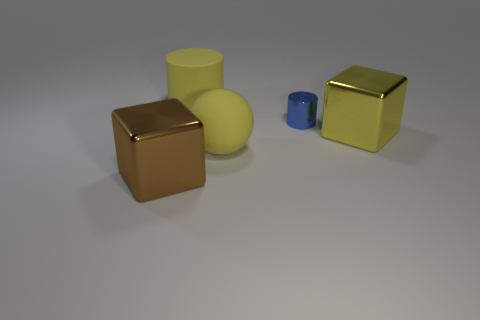Are there any other things that have the same size as the blue object?
Your answer should be very brief. No. Are there any brown cubes of the same size as the brown object?
Offer a terse response. No. Is the number of large brown metallic blocks that are behind the yellow metal cube less than the number of small brown spheres?
Offer a terse response. No. Does the yellow cylinder have the same size as the matte ball?
Give a very brief answer. Yes. What size is the thing that is made of the same material as the big ball?
Give a very brief answer. Large. How many big matte things are the same color as the large cylinder?
Make the answer very short. 1. Is the number of metal cylinders on the left side of the tiny metal cylinder less than the number of things left of the large brown metallic cube?
Your answer should be very brief. No. Is the shape of the large shiny object that is to the left of the small blue shiny object the same as  the blue metallic object?
Your response must be concise. No. Do the big cube that is behind the big brown cube and the small blue cylinder have the same material?
Keep it short and to the point. Yes. The cylinder that is behind the shiny cylinder behind the big block right of the large sphere is made of what material?
Make the answer very short. Rubber. 